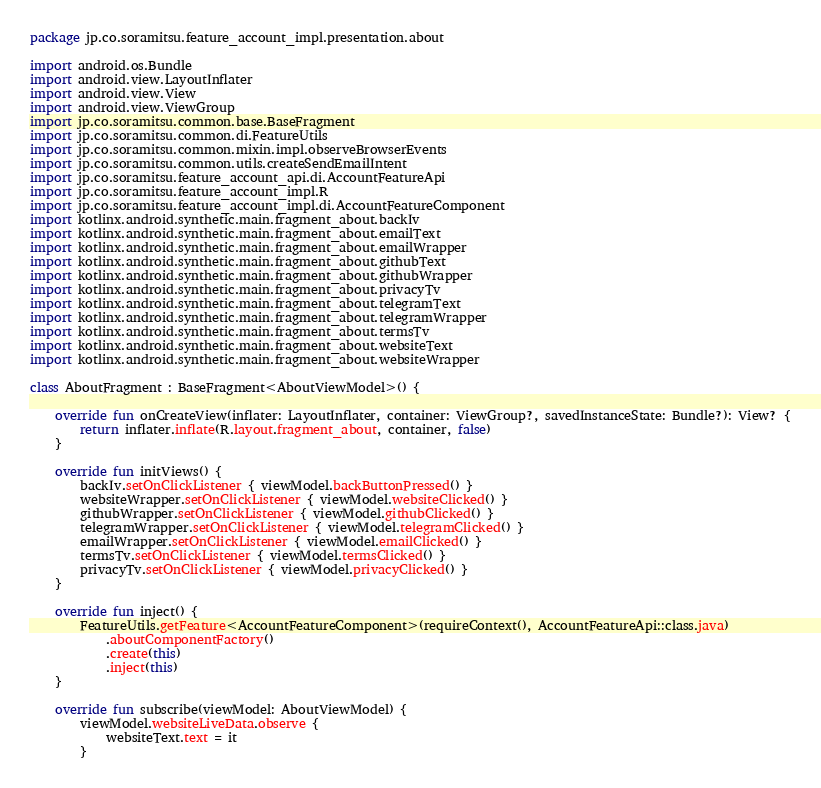<code> <loc_0><loc_0><loc_500><loc_500><_Kotlin_>package jp.co.soramitsu.feature_account_impl.presentation.about

import android.os.Bundle
import android.view.LayoutInflater
import android.view.View
import android.view.ViewGroup
import jp.co.soramitsu.common.base.BaseFragment
import jp.co.soramitsu.common.di.FeatureUtils
import jp.co.soramitsu.common.mixin.impl.observeBrowserEvents
import jp.co.soramitsu.common.utils.createSendEmailIntent
import jp.co.soramitsu.feature_account_api.di.AccountFeatureApi
import jp.co.soramitsu.feature_account_impl.R
import jp.co.soramitsu.feature_account_impl.di.AccountFeatureComponent
import kotlinx.android.synthetic.main.fragment_about.backIv
import kotlinx.android.synthetic.main.fragment_about.emailText
import kotlinx.android.synthetic.main.fragment_about.emailWrapper
import kotlinx.android.synthetic.main.fragment_about.githubText
import kotlinx.android.synthetic.main.fragment_about.githubWrapper
import kotlinx.android.synthetic.main.fragment_about.privacyTv
import kotlinx.android.synthetic.main.fragment_about.telegramText
import kotlinx.android.synthetic.main.fragment_about.telegramWrapper
import kotlinx.android.synthetic.main.fragment_about.termsTv
import kotlinx.android.synthetic.main.fragment_about.websiteText
import kotlinx.android.synthetic.main.fragment_about.websiteWrapper

class AboutFragment : BaseFragment<AboutViewModel>() {

    override fun onCreateView(inflater: LayoutInflater, container: ViewGroup?, savedInstanceState: Bundle?): View? {
        return inflater.inflate(R.layout.fragment_about, container, false)
    }

    override fun initViews() {
        backIv.setOnClickListener { viewModel.backButtonPressed() }
        websiteWrapper.setOnClickListener { viewModel.websiteClicked() }
        githubWrapper.setOnClickListener { viewModel.githubClicked() }
        telegramWrapper.setOnClickListener { viewModel.telegramClicked() }
        emailWrapper.setOnClickListener { viewModel.emailClicked() }
        termsTv.setOnClickListener { viewModel.termsClicked() }
        privacyTv.setOnClickListener { viewModel.privacyClicked() }
    }

    override fun inject() {
        FeatureUtils.getFeature<AccountFeatureComponent>(requireContext(), AccountFeatureApi::class.java)
            .aboutComponentFactory()
            .create(this)
            .inject(this)
    }

    override fun subscribe(viewModel: AboutViewModel) {
        viewModel.websiteLiveData.observe {
            websiteText.text = it
        }
</code> 